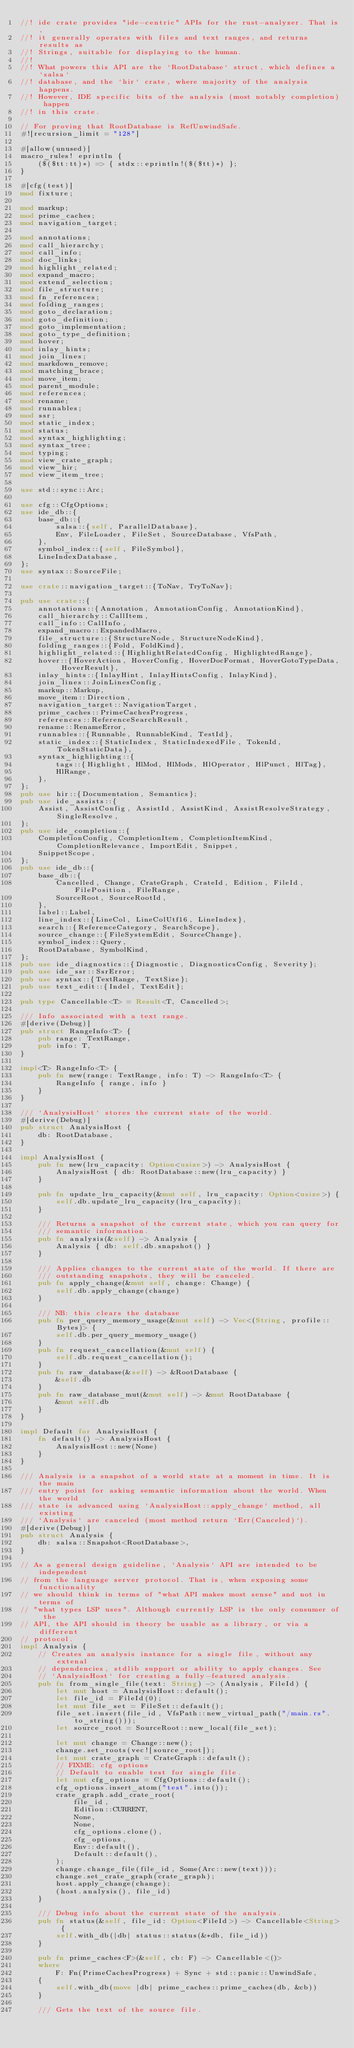Convert code to text. <code><loc_0><loc_0><loc_500><loc_500><_Rust_>//! ide crate provides "ide-centric" APIs for the rust-analyzer. That is,
//! it generally operates with files and text ranges, and returns results as
//! Strings, suitable for displaying to the human.
//!
//! What powers this API are the `RootDatabase` struct, which defines a `salsa`
//! database, and the `hir` crate, where majority of the analysis happens.
//! However, IDE specific bits of the analysis (most notably completion) happen
//! in this crate.

// For proving that RootDatabase is RefUnwindSafe.
#![recursion_limit = "128"]

#[allow(unused)]
macro_rules! eprintln {
    ($($tt:tt)*) => { stdx::eprintln!($($tt)*) };
}

#[cfg(test)]
mod fixture;

mod markup;
mod prime_caches;
mod navigation_target;

mod annotations;
mod call_hierarchy;
mod call_info;
mod doc_links;
mod highlight_related;
mod expand_macro;
mod extend_selection;
mod file_structure;
mod fn_references;
mod folding_ranges;
mod goto_declaration;
mod goto_definition;
mod goto_implementation;
mod goto_type_definition;
mod hover;
mod inlay_hints;
mod join_lines;
mod markdown_remove;
mod matching_brace;
mod move_item;
mod parent_module;
mod references;
mod rename;
mod runnables;
mod ssr;
mod static_index;
mod status;
mod syntax_highlighting;
mod syntax_tree;
mod typing;
mod view_crate_graph;
mod view_hir;
mod view_item_tree;

use std::sync::Arc;

use cfg::CfgOptions;
use ide_db::{
    base_db::{
        salsa::{self, ParallelDatabase},
        Env, FileLoader, FileSet, SourceDatabase, VfsPath,
    },
    symbol_index::{self, FileSymbol},
    LineIndexDatabase,
};
use syntax::SourceFile;

use crate::navigation_target::{ToNav, TryToNav};

pub use crate::{
    annotations::{Annotation, AnnotationConfig, AnnotationKind},
    call_hierarchy::CallItem,
    call_info::CallInfo,
    expand_macro::ExpandedMacro,
    file_structure::{StructureNode, StructureNodeKind},
    folding_ranges::{Fold, FoldKind},
    highlight_related::{HighlightRelatedConfig, HighlightedRange},
    hover::{HoverAction, HoverConfig, HoverDocFormat, HoverGotoTypeData, HoverResult},
    inlay_hints::{InlayHint, InlayHintsConfig, InlayKind},
    join_lines::JoinLinesConfig,
    markup::Markup,
    move_item::Direction,
    navigation_target::NavigationTarget,
    prime_caches::PrimeCachesProgress,
    references::ReferenceSearchResult,
    rename::RenameError,
    runnables::{Runnable, RunnableKind, TestId},
    static_index::{StaticIndex, StaticIndexedFile, TokenId, TokenStaticData},
    syntax_highlighting::{
        tags::{Highlight, HlMod, HlMods, HlOperator, HlPunct, HlTag},
        HlRange,
    },
};
pub use hir::{Documentation, Semantics};
pub use ide_assists::{
    Assist, AssistConfig, AssistId, AssistKind, AssistResolveStrategy, SingleResolve,
};
pub use ide_completion::{
    CompletionConfig, CompletionItem, CompletionItemKind, CompletionRelevance, ImportEdit, Snippet,
    SnippetScope,
};
pub use ide_db::{
    base_db::{
        Cancelled, Change, CrateGraph, CrateId, Edition, FileId, FilePosition, FileRange,
        SourceRoot, SourceRootId,
    },
    label::Label,
    line_index::{LineCol, LineColUtf16, LineIndex},
    search::{ReferenceCategory, SearchScope},
    source_change::{FileSystemEdit, SourceChange},
    symbol_index::Query,
    RootDatabase, SymbolKind,
};
pub use ide_diagnostics::{Diagnostic, DiagnosticsConfig, Severity};
pub use ide_ssr::SsrError;
pub use syntax::{TextRange, TextSize};
pub use text_edit::{Indel, TextEdit};

pub type Cancellable<T> = Result<T, Cancelled>;

/// Info associated with a text range.
#[derive(Debug)]
pub struct RangeInfo<T> {
    pub range: TextRange,
    pub info: T,
}

impl<T> RangeInfo<T> {
    pub fn new(range: TextRange, info: T) -> RangeInfo<T> {
        RangeInfo { range, info }
    }
}

/// `AnalysisHost` stores the current state of the world.
#[derive(Debug)]
pub struct AnalysisHost {
    db: RootDatabase,
}

impl AnalysisHost {
    pub fn new(lru_capacity: Option<usize>) -> AnalysisHost {
        AnalysisHost { db: RootDatabase::new(lru_capacity) }
    }

    pub fn update_lru_capacity(&mut self, lru_capacity: Option<usize>) {
        self.db.update_lru_capacity(lru_capacity);
    }

    /// Returns a snapshot of the current state, which you can query for
    /// semantic information.
    pub fn analysis(&self) -> Analysis {
        Analysis { db: self.db.snapshot() }
    }

    /// Applies changes to the current state of the world. If there are
    /// outstanding snapshots, they will be canceled.
    pub fn apply_change(&mut self, change: Change) {
        self.db.apply_change(change)
    }

    /// NB: this clears the database
    pub fn per_query_memory_usage(&mut self) -> Vec<(String, profile::Bytes)> {
        self.db.per_query_memory_usage()
    }
    pub fn request_cancellation(&mut self) {
        self.db.request_cancellation();
    }
    pub fn raw_database(&self) -> &RootDatabase {
        &self.db
    }
    pub fn raw_database_mut(&mut self) -> &mut RootDatabase {
        &mut self.db
    }
}

impl Default for AnalysisHost {
    fn default() -> AnalysisHost {
        AnalysisHost::new(None)
    }
}

/// Analysis is a snapshot of a world state at a moment in time. It is the main
/// entry point for asking semantic information about the world. When the world
/// state is advanced using `AnalysisHost::apply_change` method, all existing
/// `Analysis` are canceled (most method return `Err(Canceled)`).
#[derive(Debug)]
pub struct Analysis {
    db: salsa::Snapshot<RootDatabase>,
}

// As a general design guideline, `Analysis` API are intended to be independent
// from the language server protocol. That is, when exposing some functionality
// we should think in terms of "what API makes most sense" and not in terms of
// "what types LSP uses". Although currently LSP is the only consumer of the
// API, the API should in theory be usable as a library, or via a different
// protocol.
impl Analysis {
    // Creates an analysis instance for a single file, without any extenal
    // dependencies, stdlib support or ability to apply changes. See
    // `AnalysisHost` for creating a fully-featured analysis.
    pub fn from_single_file(text: String) -> (Analysis, FileId) {
        let mut host = AnalysisHost::default();
        let file_id = FileId(0);
        let mut file_set = FileSet::default();
        file_set.insert(file_id, VfsPath::new_virtual_path("/main.rs".to_string()));
        let source_root = SourceRoot::new_local(file_set);

        let mut change = Change::new();
        change.set_roots(vec![source_root]);
        let mut crate_graph = CrateGraph::default();
        // FIXME: cfg options
        // Default to enable test for single file.
        let mut cfg_options = CfgOptions::default();
        cfg_options.insert_atom("test".into());
        crate_graph.add_crate_root(
            file_id,
            Edition::CURRENT,
            None,
            None,
            cfg_options.clone(),
            cfg_options,
            Env::default(),
            Default::default(),
        );
        change.change_file(file_id, Some(Arc::new(text)));
        change.set_crate_graph(crate_graph);
        host.apply_change(change);
        (host.analysis(), file_id)
    }

    /// Debug info about the current state of the analysis.
    pub fn status(&self, file_id: Option<FileId>) -> Cancellable<String> {
        self.with_db(|db| status::status(&*db, file_id))
    }

    pub fn prime_caches<F>(&self, cb: F) -> Cancellable<()>
    where
        F: Fn(PrimeCachesProgress) + Sync + std::panic::UnwindSafe,
    {
        self.with_db(move |db| prime_caches::prime_caches(db, &cb))
    }

    /// Gets the text of the source file.</code> 